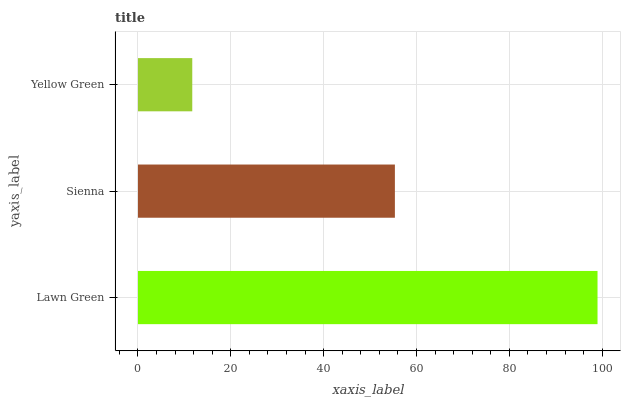Is Yellow Green the minimum?
Answer yes or no. Yes. Is Lawn Green the maximum?
Answer yes or no. Yes. Is Sienna the minimum?
Answer yes or no. No. Is Sienna the maximum?
Answer yes or no. No. Is Lawn Green greater than Sienna?
Answer yes or no. Yes. Is Sienna less than Lawn Green?
Answer yes or no. Yes. Is Sienna greater than Lawn Green?
Answer yes or no. No. Is Lawn Green less than Sienna?
Answer yes or no. No. Is Sienna the high median?
Answer yes or no. Yes. Is Sienna the low median?
Answer yes or no. Yes. Is Yellow Green the high median?
Answer yes or no. No. Is Yellow Green the low median?
Answer yes or no. No. 